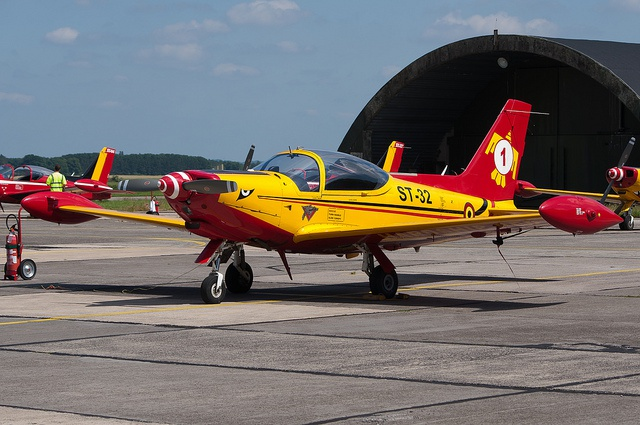Describe the objects in this image and their specific colors. I can see airplane in gray, black, maroon, gold, and orange tones, airplane in gray, black, brown, and blue tones, airplane in gray, black, and maroon tones, and people in gray, khaki, and black tones in this image. 